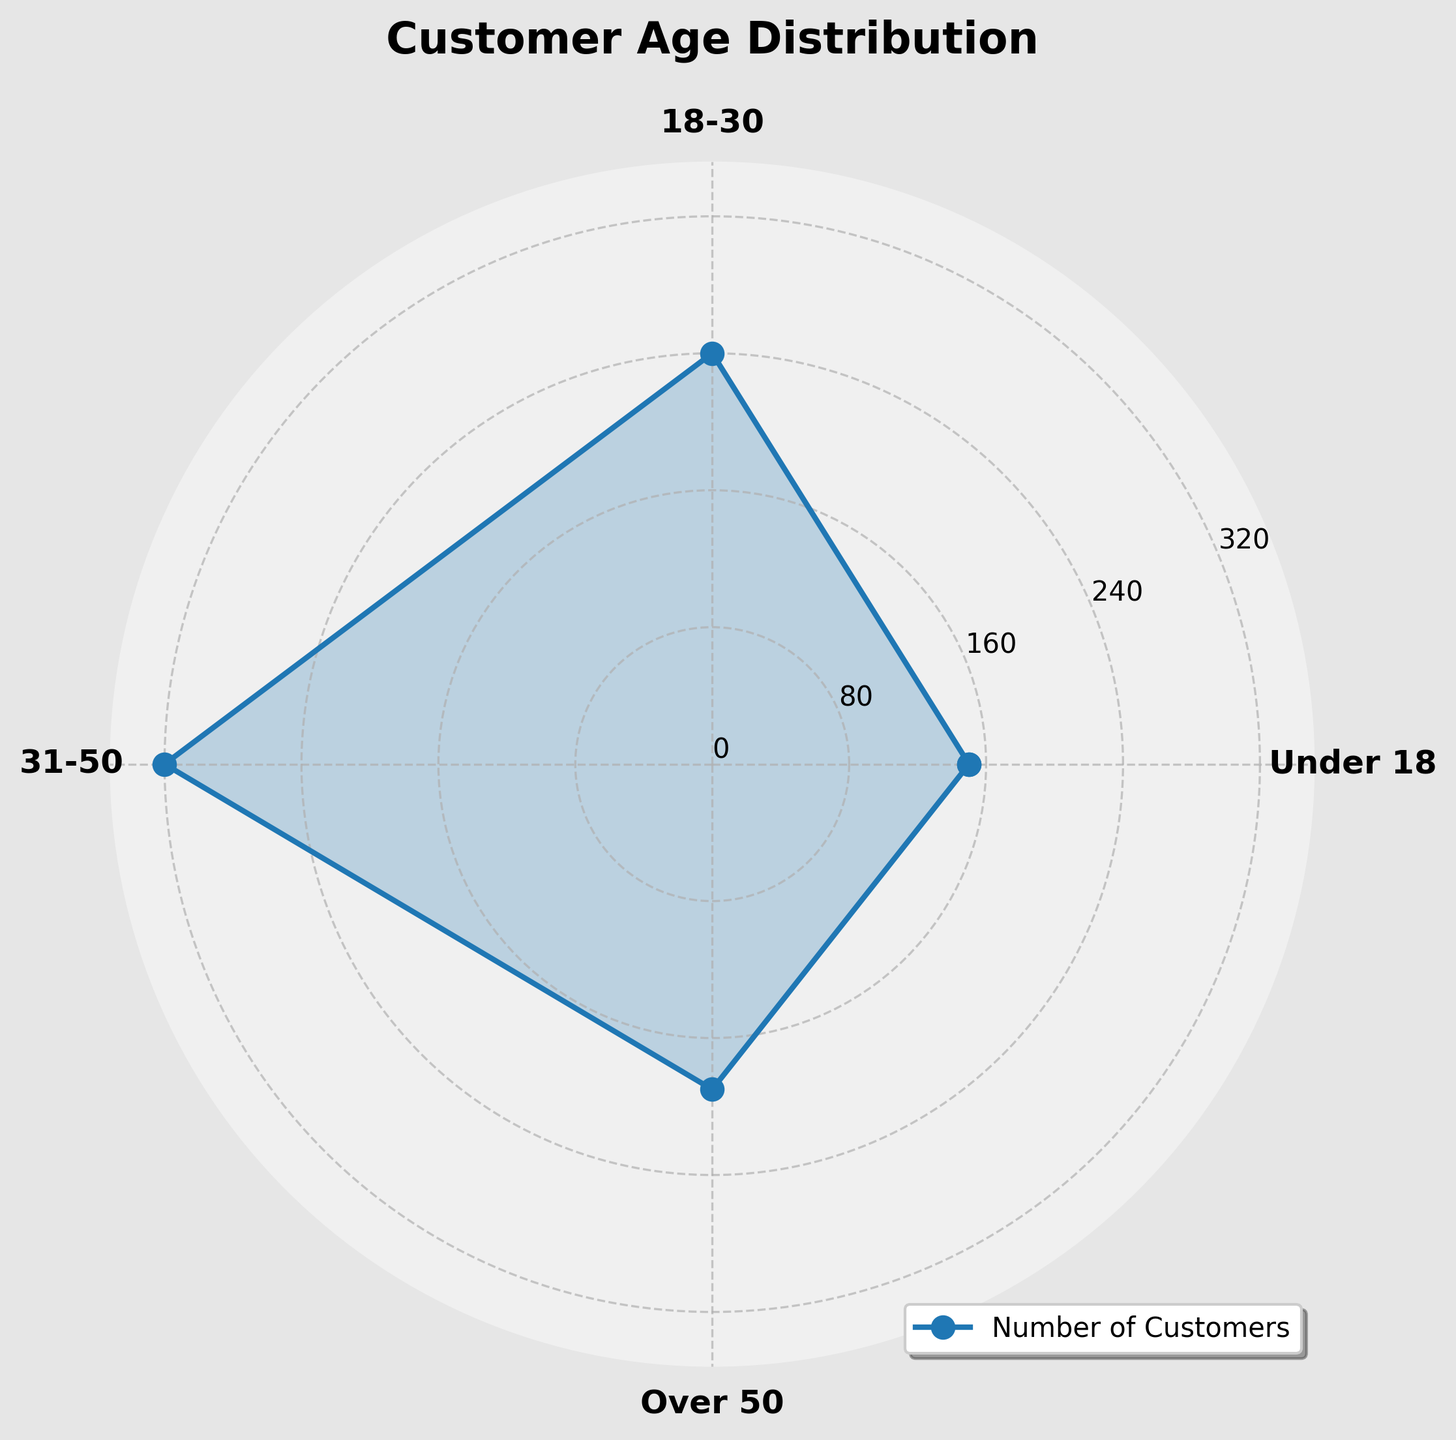What is the title of the figure? The title of the figure is usually located at the top center and indicates what the chart represents. In this case, it reads "Customer Age Distribution".
Answer: Customer Age Distribution How many age groups are represented in the chart? By counting the distinct labels along the angular axis, we can see the number of age groups represented. Here, there are four labeled age groups: Under 18, 18-30, 31-50, and Over 50.
Answer: 4 Which age group has the highest number of customers? The highest point on the radial axis indicates the age group with the most customers. Looking at the chart, the 31-50 age group reaches the highest point.
Answer: 31-50 What is the approximate number of customers in the 'Over 50' age group? The radial distance from the center to the point for the 'Over 50' age group provides the number of customers. The 'Over 50' group is close to 190 on the radial axis.
Answer: 190 Compare the number of customers in the '18-30' and '31-50' age groups. Which has more, and by how much? By looking at the radial distance for both groups, the '31-50' group is higher. The number for '31-50' is 320 and for '18-30' it is 240. The difference is 320 - 240.
Answer: 31-50 has 80 more What is the total number of customers represented in the chart? Summing the values for all age groups: 150 (Under 18) + 240 (18-30) + 320 (31-50) + 190 (Over 50). The total is 150 + 240 + 320 + 190.
Answer: 900 Which age group has the lowest number of customers and what is that number? The shortest radial distance from the center indicates the age group with the fewest customers. The 'Under 18' age group, with 150 customers, is the smallest.
Answer: Under 18 with 150 What is the range of customer numbers across different age groups? The range is the difference between the highest and lowest values. The highest value is 320 (for 31-50) and the lowest is 150 (for Under 18), so the range is 320 - 150.
Answer: 170 What is the average number of customers across all age groups? The average is the total number of customers divided by the number of age groups. The total number is 900 and there are 4 age groups. So, the average is 900 / 4.
Answer: 225 What percentage of the total customers fall into the '31-50' age group? To find this, divide the number of customers in the '31-50' group by the total number of customers and multiply by 100. Therefore, (320 / 900) * 100.
Answer: 35.56% 